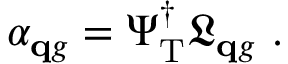<formula> <loc_0><loc_0><loc_500><loc_500>\alpha _ { \mathbf q g } = \Psi _ { T } ^ { \dagger } \mathfrak L _ { \mathbf q g } .</formula> 